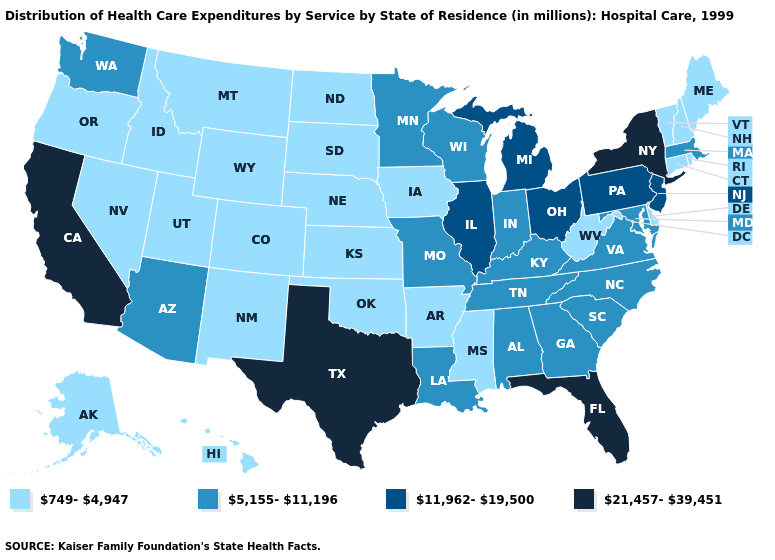What is the value of Vermont?
Keep it brief. 749-4,947. Name the states that have a value in the range 11,962-19,500?
Give a very brief answer. Illinois, Michigan, New Jersey, Ohio, Pennsylvania. Among the states that border Delaware , which have the highest value?
Short answer required. New Jersey, Pennsylvania. Does the first symbol in the legend represent the smallest category?
Short answer required. Yes. Is the legend a continuous bar?
Quick response, please. No. Name the states that have a value in the range 749-4,947?
Be succinct. Alaska, Arkansas, Colorado, Connecticut, Delaware, Hawaii, Idaho, Iowa, Kansas, Maine, Mississippi, Montana, Nebraska, Nevada, New Hampshire, New Mexico, North Dakota, Oklahoma, Oregon, Rhode Island, South Dakota, Utah, Vermont, West Virginia, Wyoming. What is the highest value in the MidWest ?
Answer briefly. 11,962-19,500. What is the highest value in the West ?
Write a very short answer. 21,457-39,451. What is the highest value in the MidWest ?
Write a very short answer. 11,962-19,500. Does Mississippi have the lowest value in the South?
Write a very short answer. Yes. Among the states that border Vermont , which have the lowest value?
Concise answer only. New Hampshire. Name the states that have a value in the range 5,155-11,196?
Short answer required. Alabama, Arizona, Georgia, Indiana, Kentucky, Louisiana, Maryland, Massachusetts, Minnesota, Missouri, North Carolina, South Carolina, Tennessee, Virginia, Washington, Wisconsin. Name the states that have a value in the range 21,457-39,451?
Answer briefly. California, Florida, New York, Texas. Among the states that border Oklahoma , does Missouri have the highest value?
Give a very brief answer. No. 